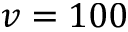Convert formula to latex. <formula><loc_0><loc_0><loc_500><loc_500>v = 1 0 0</formula> 